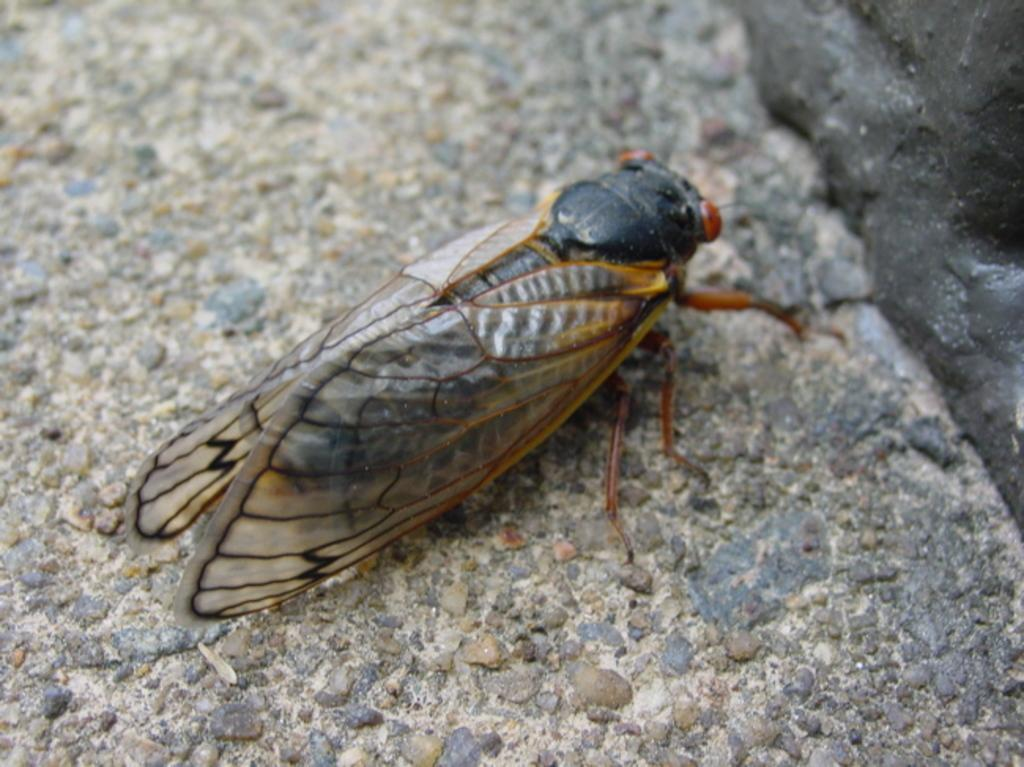What type of creature is present in the image? There is an insect in the image. Can you describe the coloration of the insect? The insect has black and brown coloration. What is the background or surface that the insect is on? The insect is on a gray and brown color surface. How many beans can be seen next to the insect in the image? There are no beans present in the image. Can you describe the fingerprint of the visitor who touched the insect in the image? There is no mention of a visitor or any interaction with the insect in the image, so we cannot describe a fingerprint. 